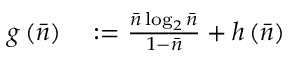<formula> <loc_0><loc_0><loc_500><loc_500>\begin{array} { r l } { g \left ( \bar { n } \right ) } & \colon = \frac { \bar { n } \log _ { 2 } \bar { n } } { 1 - \bar { n } } + h \left ( \bar { n } \right ) } \end{array}</formula> 